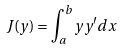Convert formula to latex. <formula><loc_0><loc_0><loc_500><loc_500>J ( y ) = \int _ { a } ^ { b } y y ^ { \prime } d x</formula> 